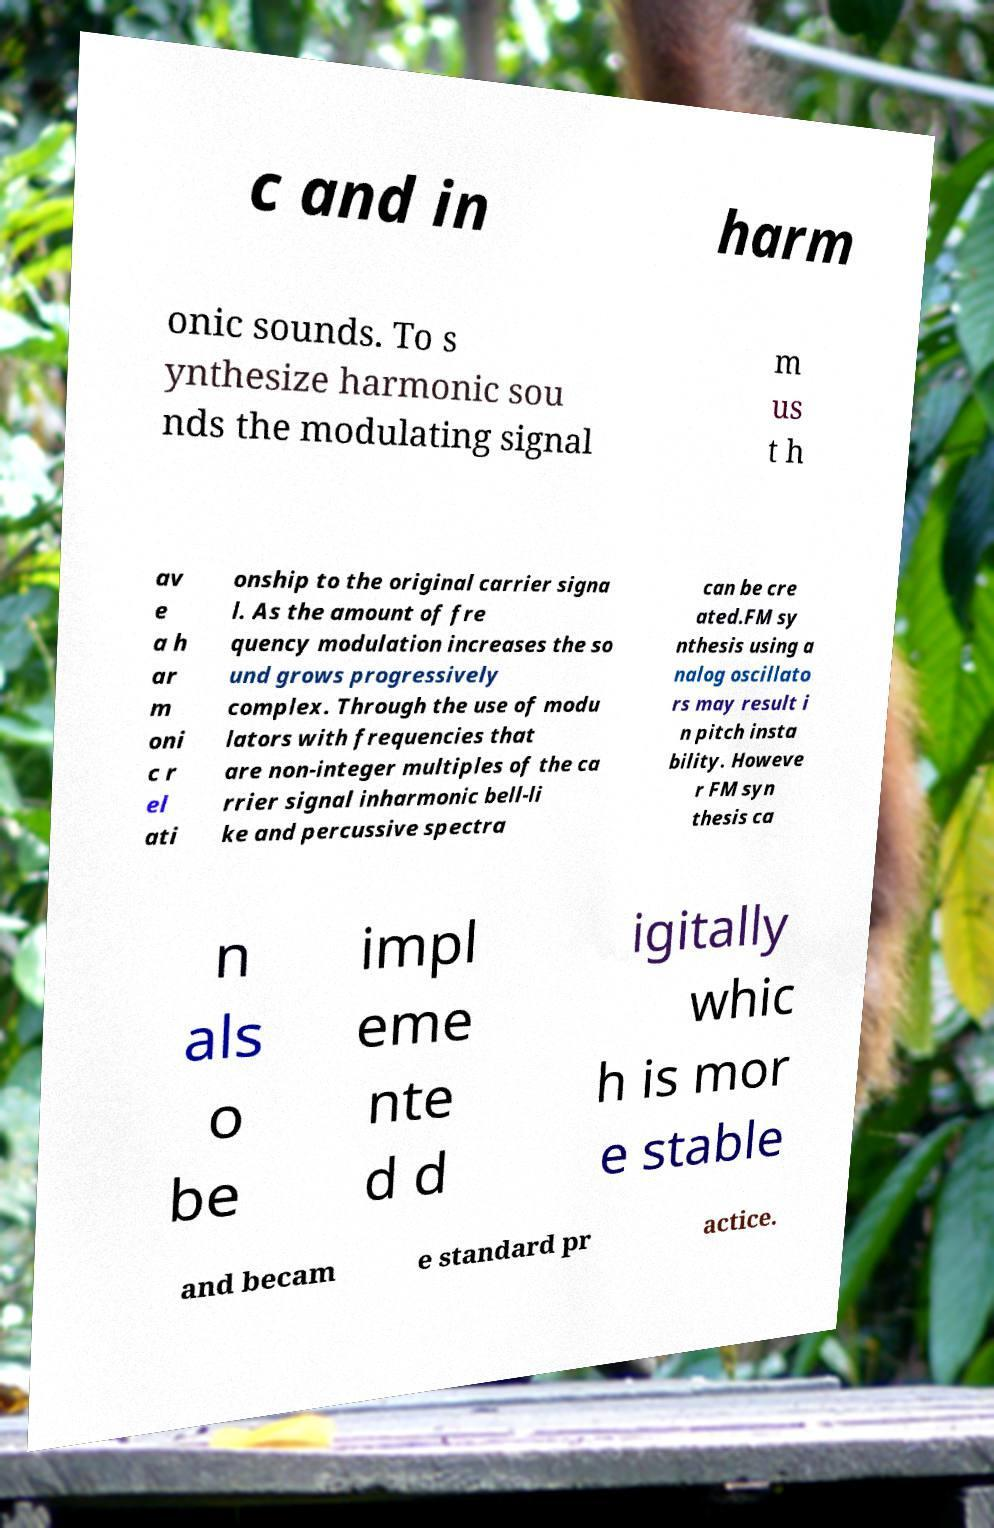Please read and relay the text visible in this image. What does it say? c and in harm onic sounds. To s ynthesize harmonic sou nds the modulating signal m us t h av e a h ar m oni c r el ati onship to the original carrier signa l. As the amount of fre quency modulation increases the so und grows progressively complex. Through the use of modu lators with frequencies that are non-integer multiples of the ca rrier signal inharmonic bell-li ke and percussive spectra can be cre ated.FM sy nthesis using a nalog oscillato rs may result i n pitch insta bility. Howeve r FM syn thesis ca n als o be impl eme nte d d igitally whic h is mor e stable and becam e standard pr actice. 